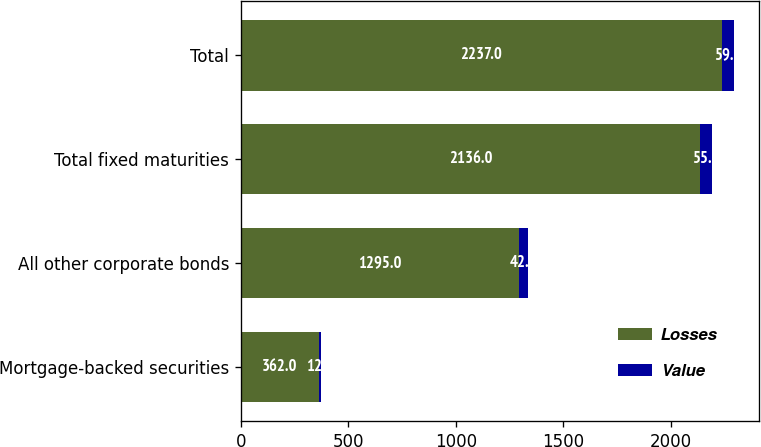Convert chart to OTSL. <chart><loc_0><loc_0><loc_500><loc_500><stacked_bar_chart><ecel><fcel>Mortgage-backed securities<fcel>All other corporate bonds<fcel>Total fixed maturities<fcel>Total<nl><fcel>Losses<fcel>362<fcel>1295<fcel>2136<fcel>2237<nl><fcel>Value<fcel>12<fcel>42<fcel>55<fcel>59<nl></chart> 